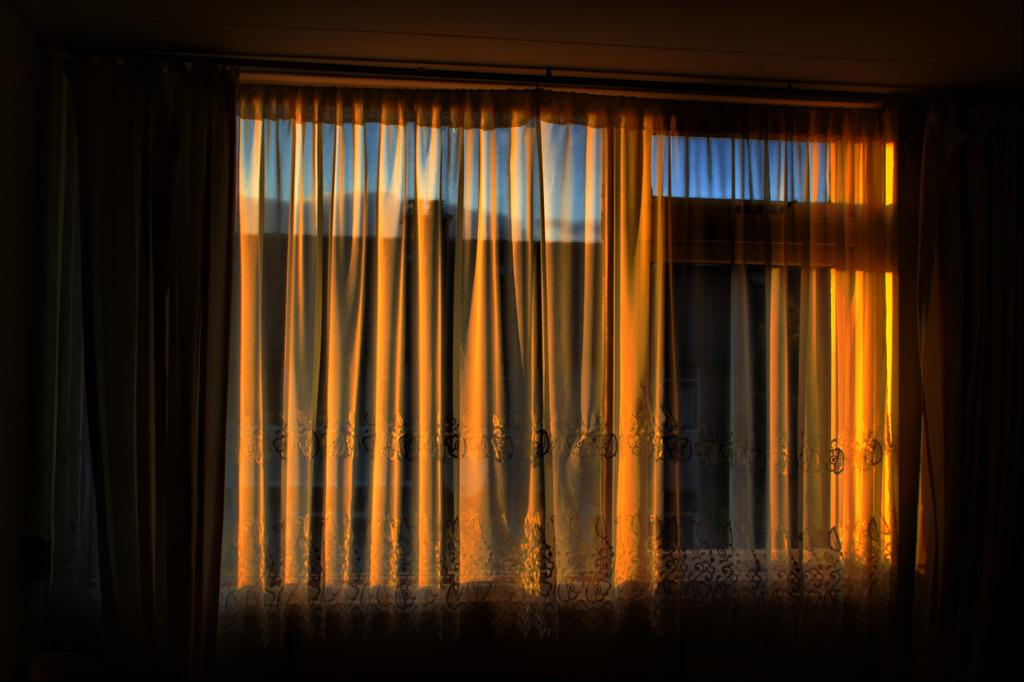What can be seen in the image that allows light to enter a room? There is a window in the image. What is present near the window to provide privacy or control light? There is a curtain in the image. What type of account is being discussed in the image? There is no account being discussed in the image; it only features a window and a curtain. How many trousers are hanging on the curtain rod in the image? There are no trousers present in the image; it only features a window and a curtain. 